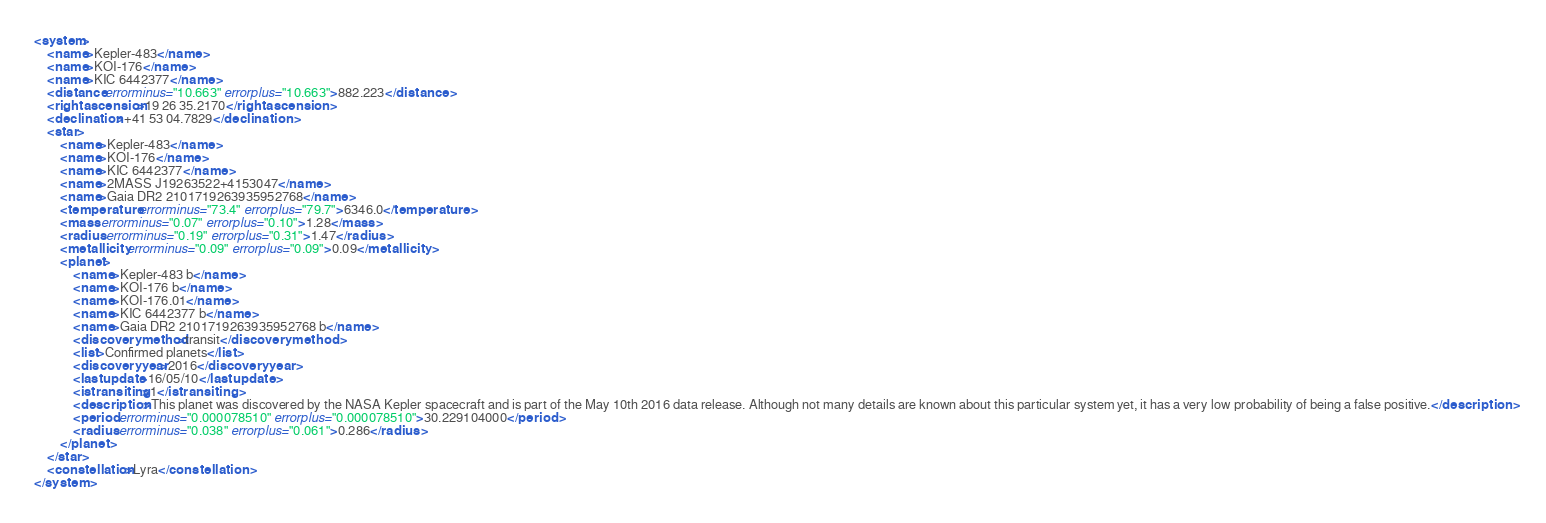<code> <loc_0><loc_0><loc_500><loc_500><_XML_><system>
	<name>Kepler-483</name>
	<name>KOI-176</name>
	<name>KIC 6442377</name>
	<distance errorminus="10.663" errorplus="10.663">882.223</distance>
	<rightascension>19 26 35.2170</rightascension>
	<declination>+41 53 04.7829</declination>
	<star>
		<name>Kepler-483</name>
		<name>KOI-176</name>
		<name>KIC 6442377</name>
		<name>2MASS J19263522+4153047</name>
		<name>Gaia DR2 2101719263935952768</name>
		<temperature errorminus="73.4" errorplus="79.7">6346.0</temperature>
		<mass errorminus="0.07" errorplus="0.10">1.28</mass>
		<radius errorminus="0.19" errorplus="0.31">1.47</radius>
		<metallicity errorminus="0.09" errorplus="0.09">0.09</metallicity>
		<planet>
			<name>Kepler-483 b</name>
			<name>KOI-176 b</name>
			<name>KOI-176.01</name>
			<name>KIC 6442377 b</name>
			<name>Gaia DR2 2101719263935952768 b</name>
			<discoverymethod>transit</discoverymethod>
			<list>Confirmed planets</list>
			<discoveryyear>2016</discoveryyear>
			<lastupdate>16/05/10</lastupdate>
			<istransiting>1</istransiting>
			<description>This planet was discovered by the NASA Kepler spacecraft and is part of the May 10th 2016 data release. Although not many details are known about this particular system yet, it has a very low probability of being a false positive.</description>
			<period errorminus="0.000078510" errorplus="0.000078510">30.229104000</period>
			<radius errorminus="0.038" errorplus="0.061">0.286</radius>
		</planet>
	</star>
	<constellation>Lyra</constellation>
</system>
</code> 